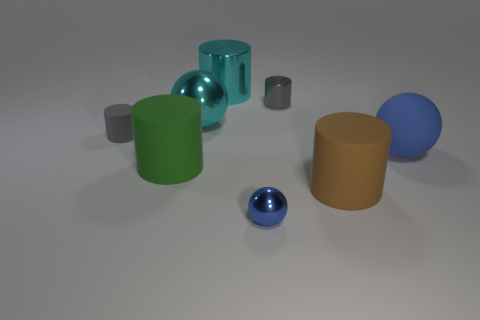Subtract all large balls. How many balls are left? 1 Add 1 large green matte cylinders. How many objects exist? 9 Subtract all green cylinders. How many cylinders are left? 4 Subtract 2 balls. How many balls are left? 1 Subtract all cylinders. How many objects are left? 3 Subtract 0 purple spheres. How many objects are left? 8 Subtract all brown balls. Subtract all cyan blocks. How many balls are left? 3 Subtract all purple cubes. How many brown spheres are left? 0 Subtract all small red matte cubes. Subtract all blue metal spheres. How many objects are left? 7 Add 3 blue balls. How many blue balls are left? 5 